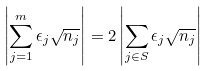<formula> <loc_0><loc_0><loc_500><loc_500>\left | \sum _ { j = 1 } ^ { m } \epsilon _ { j } \sqrt { n _ { j } } \right | = 2 \left | \sum _ { j \in S } \epsilon _ { j } \sqrt { n _ { j } } \right |</formula> 